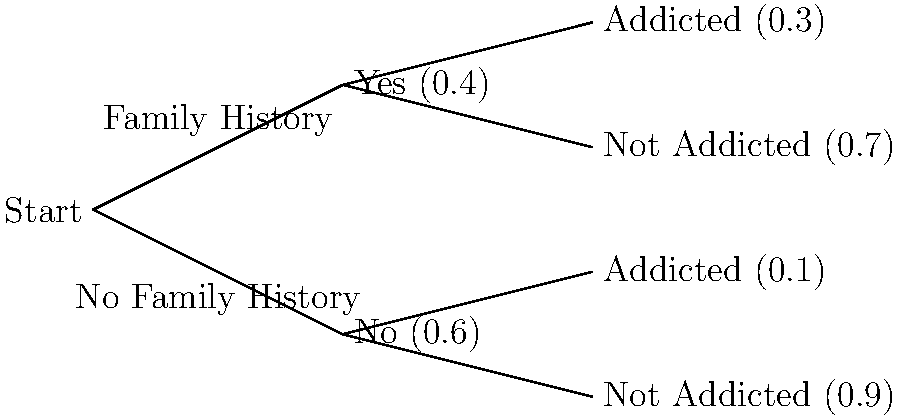A tree diagram illustrates the probability of drug addiction based on family history. If a person has a family history of addiction, there's a 30% chance they'll become addicted. Without a family history, the chance drops to 10%. Given that 40% of the population has a family history of addiction, what is the overall probability that a randomly selected individual will become addicted to drugs? Let's approach this step-by-step:

1) First, we need to identify the two possible paths that lead to addiction:
   a) Having a family history AND becoming addicted
   b) Not having a family history AND becoming addicted

2) Let's calculate the probability for each path:
   a) P(Family History and Addicted) = P(Family History) × P(Addicted | Family History)
      = 0.4 × 0.3 = 0.12

   b) P(No Family History and Addicted) = P(No Family History) × P(Addicted | No Family History)
      = 0.6 × 0.1 = 0.06

3) The overall probability of becoming addicted is the sum of these two probabilities:
   P(Addicted) = P(Family History and Addicted) + P(No Family History and Addicted)
                = 0.12 + 0.06 = 0.18

4) Therefore, the probability that a randomly selected individual will become addicted to drugs is 0.18 or 18%.
Answer: 0.18 or 18% 